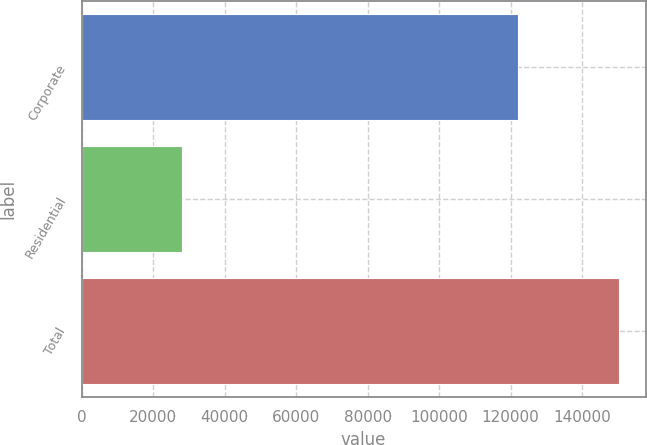Convert chart to OTSL. <chart><loc_0><loc_0><loc_500><loc_500><bar_chart><fcel>Corporate<fcel>Residential<fcel>Total<nl><fcel>122096<fcel>28176<fcel>150272<nl></chart> 